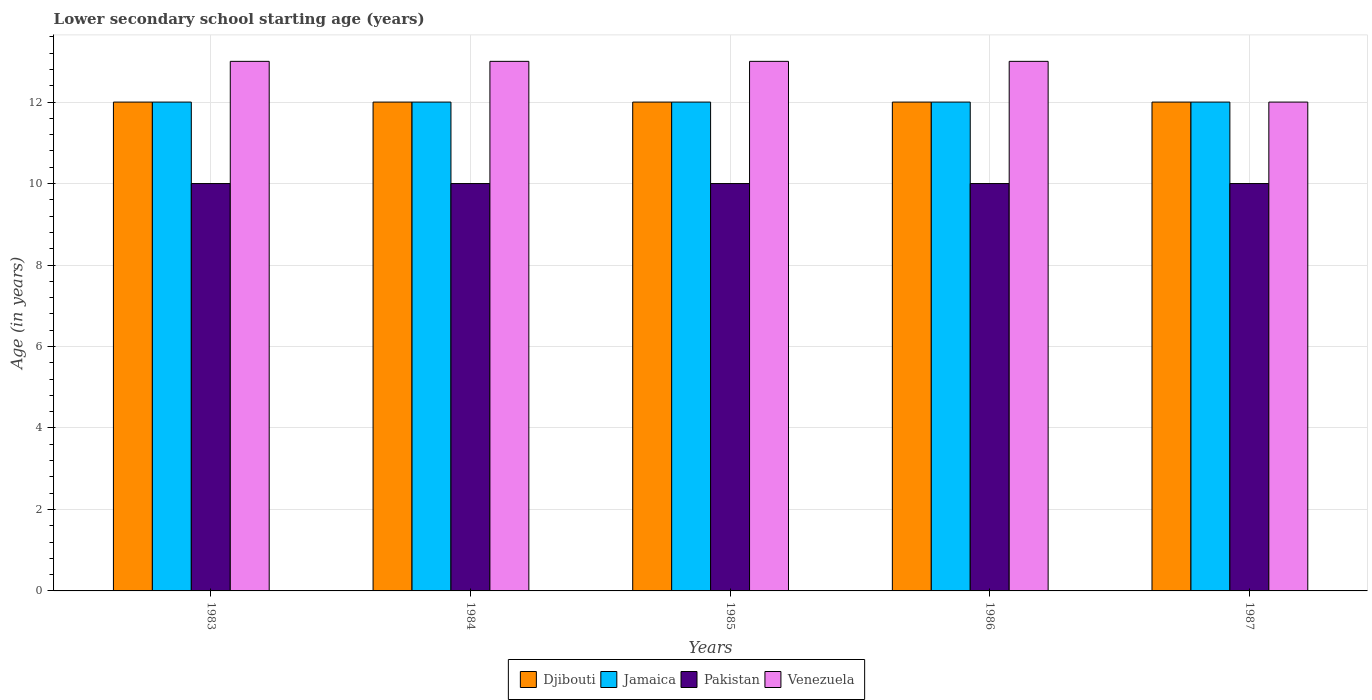Are the number of bars per tick equal to the number of legend labels?
Give a very brief answer. Yes. Are the number of bars on each tick of the X-axis equal?
Your answer should be compact. Yes. How many bars are there on the 2nd tick from the left?
Ensure brevity in your answer.  4. What is the label of the 5th group of bars from the left?
Ensure brevity in your answer.  1987. What is the lower secondary school starting age of children in Jamaica in 1985?
Provide a short and direct response. 12. Across all years, what is the maximum lower secondary school starting age of children in Venezuela?
Provide a succinct answer. 13. Across all years, what is the minimum lower secondary school starting age of children in Pakistan?
Your response must be concise. 10. In which year was the lower secondary school starting age of children in Djibouti minimum?
Your response must be concise. 1983. What is the total lower secondary school starting age of children in Jamaica in the graph?
Offer a very short reply. 60. What is the difference between the lower secondary school starting age of children in Venezuela in 1985 and that in 1987?
Your answer should be compact. 1. What is the difference between the lower secondary school starting age of children in Pakistan in 1983 and the lower secondary school starting age of children in Venezuela in 1985?
Make the answer very short. -3. In the year 1985, what is the difference between the lower secondary school starting age of children in Pakistan and lower secondary school starting age of children in Djibouti?
Make the answer very short. -2. What is the ratio of the lower secondary school starting age of children in Pakistan in 1984 to that in 1985?
Offer a terse response. 1. What is the difference between the highest and the lowest lower secondary school starting age of children in Venezuela?
Provide a short and direct response. 1. Is the sum of the lower secondary school starting age of children in Jamaica in 1983 and 1985 greater than the maximum lower secondary school starting age of children in Venezuela across all years?
Ensure brevity in your answer.  Yes. What does the 2nd bar from the left in 1986 represents?
Offer a terse response. Jamaica. What does the 3rd bar from the right in 1983 represents?
Provide a short and direct response. Jamaica. What is the difference between two consecutive major ticks on the Y-axis?
Give a very brief answer. 2. Are the values on the major ticks of Y-axis written in scientific E-notation?
Your answer should be very brief. No. Does the graph contain grids?
Ensure brevity in your answer.  Yes. How many legend labels are there?
Your answer should be very brief. 4. How are the legend labels stacked?
Offer a very short reply. Horizontal. What is the title of the graph?
Give a very brief answer. Lower secondary school starting age (years). Does "Eritrea" appear as one of the legend labels in the graph?
Your answer should be compact. No. What is the label or title of the Y-axis?
Make the answer very short. Age (in years). What is the Age (in years) in Djibouti in 1983?
Provide a short and direct response. 12. What is the Age (in years) of Jamaica in 1983?
Offer a very short reply. 12. What is the Age (in years) of Pakistan in 1983?
Give a very brief answer. 10. What is the Age (in years) in Djibouti in 1984?
Provide a short and direct response. 12. What is the Age (in years) in Jamaica in 1984?
Ensure brevity in your answer.  12. What is the Age (in years) in Pakistan in 1984?
Make the answer very short. 10. What is the Age (in years) of Venezuela in 1984?
Provide a short and direct response. 13. What is the Age (in years) of Jamaica in 1985?
Your answer should be very brief. 12. What is the Age (in years) in Pakistan in 1985?
Your answer should be very brief. 10. What is the Age (in years) in Venezuela in 1985?
Make the answer very short. 13. What is the Age (in years) in Jamaica in 1986?
Make the answer very short. 12. What is the Age (in years) of Venezuela in 1986?
Make the answer very short. 13. Across all years, what is the maximum Age (in years) in Venezuela?
Give a very brief answer. 13. Across all years, what is the minimum Age (in years) of Djibouti?
Make the answer very short. 12. Across all years, what is the minimum Age (in years) of Jamaica?
Give a very brief answer. 12. Across all years, what is the minimum Age (in years) in Pakistan?
Your answer should be very brief. 10. Across all years, what is the minimum Age (in years) in Venezuela?
Your response must be concise. 12. What is the total Age (in years) in Jamaica in the graph?
Your response must be concise. 60. What is the total Age (in years) of Venezuela in the graph?
Provide a short and direct response. 64. What is the difference between the Age (in years) of Djibouti in 1983 and that in 1984?
Offer a very short reply. 0. What is the difference between the Age (in years) of Pakistan in 1983 and that in 1984?
Your answer should be compact. 0. What is the difference between the Age (in years) in Jamaica in 1983 and that in 1986?
Your answer should be compact. 0. What is the difference between the Age (in years) in Pakistan in 1983 and that in 1986?
Offer a terse response. 0. What is the difference between the Age (in years) in Venezuela in 1983 and that in 1986?
Your answer should be very brief. 0. What is the difference between the Age (in years) in Djibouti in 1983 and that in 1987?
Keep it short and to the point. 0. What is the difference between the Age (in years) in Jamaica in 1983 and that in 1987?
Make the answer very short. 0. What is the difference between the Age (in years) of Venezuela in 1983 and that in 1987?
Offer a very short reply. 1. What is the difference between the Age (in years) of Djibouti in 1984 and that in 1985?
Keep it short and to the point. 0. What is the difference between the Age (in years) of Jamaica in 1984 and that in 1985?
Keep it short and to the point. 0. What is the difference between the Age (in years) in Pakistan in 1984 and that in 1985?
Offer a very short reply. 0. What is the difference between the Age (in years) of Djibouti in 1984 and that in 1986?
Provide a short and direct response. 0. What is the difference between the Age (in years) of Pakistan in 1984 and that in 1986?
Your response must be concise. 0. What is the difference between the Age (in years) of Venezuela in 1984 and that in 1986?
Provide a succinct answer. 0. What is the difference between the Age (in years) in Jamaica in 1984 and that in 1987?
Offer a terse response. 0. What is the difference between the Age (in years) in Venezuela in 1984 and that in 1987?
Provide a succinct answer. 1. What is the difference between the Age (in years) of Djibouti in 1985 and that in 1987?
Give a very brief answer. 0. What is the difference between the Age (in years) of Pakistan in 1985 and that in 1987?
Make the answer very short. 0. What is the difference between the Age (in years) of Venezuela in 1985 and that in 1987?
Ensure brevity in your answer.  1. What is the difference between the Age (in years) in Djibouti in 1986 and that in 1987?
Make the answer very short. 0. What is the difference between the Age (in years) of Pakistan in 1986 and that in 1987?
Ensure brevity in your answer.  0. What is the difference between the Age (in years) of Djibouti in 1983 and the Age (in years) of Jamaica in 1984?
Give a very brief answer. 0. What is the difference between the Age (in years) in Djibouti in 1983 and the Age (in years) in Venezuela in 1984?
Keep it short and to the point. -1. What is the difference between the Age (in years) of Pakistan in 1983 and the Age (in years) of Venezuela in 1984?
Your answer should be very brief. -3. What is the difference between the Age (in years) of Jamaica in 1983 and the Age (in years) of Pakistan in 1985?
Your answer should be compact. 2. What is the difference between the Age (in years) of Jamaica in 1983 and the Age (in years) of Venezuela in 1985?
Ensure brevity in your answer.  -1. What is the difference between the Age (in years) in Pakistan in 1983 and the Age (in years) in Venezuela in 1985?
Provide a succinct answer. -3. What is the difference between the Age (in years) in Djibouti in 1983 and the Age (in years) in Jamaica in 1986?
Your response must be concise. 0. What is the difference between the Age (in years) of Djibouti in 1983 and the Age (in years) of Venezuela in 1986?
Your answer should be compact. -1. What is the difference between the Age (in years) in Jamaica in 1983 and the Age (in years) in Pakistan in 1986?
Ensure brevity in your answer.  2. What is the difference between the Age (in years) of Djibouti in 1983 and the Age (in years) of Pakistan in 1987?
Your answer should be very brief. 2. What is the difference between the Age (in years) of Jamaica in 1983 and the Age (in years) of Pakistan in 1987?
Your answer should be very brief. 2. What is the difference between the Age (in years) of Jamaica in 1983 and the Age (in years) of Venezuela in 1987?
Keep it short and to the point. 0. What is the difference between the Age (in years) in Pakistan in 1983 and the Age (in years) in Venezuela in 1987?
Your response must be concise. -2. What is the difference between the Age (in years) in Djibouti in 1984 and the Age (in years) in Jamaica in 1985?
Your answer should be very brief. 0. What is the difference between the Age (in years) of Djibouti in 1984 and the Age (in years) of Venezuela in 1985?
Offer a very short reply. -1. What is the difference between the Age (in years) in Jamaica in 1984 and the Age (in years) in Pakistan in 1985?
Give a very brief answer. 2. What is the difference between the Age (in years) of Jamaica in 1984 and the Age (in years) of Venezuela in 1985?
Offer a terse response. -1. What is the difference between the Age (in years) in Pakistan in 1984 and the Age (in years) in Venezuela in 1985?
Keep it short and to the point. -3. What is the difference between the Age (in years) in Djibouti in 1984 and the Age (in years) in Pakistan in 1986?
Give a very brief answer. 2. What is the difference between the Age (in years) of Djibouti in 1984 and the Age (in years) of Venezuela in 1986?
Offer a terse response. -1. What is the difference between the Age (in years) of Jamaica in 1984 and the Age (in years) of Pakistan in 1986?
Your answer should be very brief. 2. What is the difference between the Age (in years) in Jamaica in 1984 and the Age (in years) in Venezuela in 1986?
Your answer should be very brief. -1. What is the difference between the Age (in years) in Djibouti in 1984 and the Age (in years) in Jamaica in 1987?
Ensure brevity in your answer.  0. What is the difference between the Age (in years) in Djibouti in 1984 and the Age (in years) in Pakistan in 1987?
Offer a terse response. 2. What is the difference between the Age (in years) of Djibouti in 1984 and the Age (in years) of Venezuela in 1987?
Provide a short and direct response. 0. What is the difference between the Age (in years) in Jamaica in 1984 and the Age (in years) in Pakistan in 1987?
Your response must be concise. 2. What is the difference between the Age (in years) in Pakistan in 1984 and the Age (in years) in Venezuela in 1987?
Make the answer very short. -2. What is the difference between the Age (in years) in Djibouti in 1985 and the Age (in years) in Jamaica in 1986?
Provide a short and direct response. 0. What is the difference between the Age (in years) of Jamaica in 1985 and the Age (in years) of Pakistan in 1986?
Ensure brevity in your answer.  2. What is the difference between the Age (in years) in Jamaica in 1985 and the Age (in years) in Venezuela in 1986?
Ensure brevity in your answer.  -1. What is the difference between the Age (in years) of Jamaica in 1985 and the Age (in years) of Pakistan in 1987?
Give a very brief answer. 2. What is the difference between the Age (in years) in Jamaica in 1985 and the Age (in years) in Venezuela in 1987?
Your answer should be very brief. 0. What is the difference between the Age (in years) in Pakistan in 1985 and the Age (in years) in Venezuela in 1987?
Provide a succinct answer. -2. What is the difference between the Age (in years) in Jamaica in 1986 and the Age (in years) in Pakistan in 1987?
Offer a very short reply. 2. What is the difference between the Age (in years) of Pakistan in 1986 and the Age (in years) of Venezuela in 1987?
Provide a succinct answer. -2. What is the average Age (in years) in Djibouti per year?
Your answer should be very brief. 12. What is the average Age (in years) in Jamaica per year?
Your answer should be compact. 12. What is the average Age (in years) of Venezuela per year?
Keep it short and to the point. 12.8. In the year 1983, what is the difference between the Age (in years) in Djibouti and Age (in years) in Pakistan?
Offer a terse response. 2. In the year 1983, what is the difference between the Age (in years) of Djibouti and Age (in years) of Venezuela?
Make the answer very short. -1. In the year 1983, what is the difference between the Age (in years) of Jamaica and Age (in years) of Venezuela?
Provide a short and direct response. -1. In the year 1984, what is the difference between the Age (in years) in Djibouti and Age (in years) in Jamaica?
Make the answer very short. 0. In the year 1984, what is the difference between the Age (in years) in Jamaica and Age (in years) in Pakistan?
Your answer should be compact. 2. In the year 1984, what is the difference between the Age (in years) in Jamaica and Age (in years) in Venezuela?
Ensure brevity in your answer.  -1. In the year 1985, what is the difference between the Age (in years) in Djibouti and Age (in years) in Jamaica?
Your answer should be compact. 0. In the year 1985, what is the difference between the Age (in years) of Djibouti and Age (in years) of Venezuela?
Keep it short and to the point. -1. In the year 1985, what is the difference between the Age (in years) in Jamaica and Age (in years) in Venezuela?
Provide a succinct answer. -1. In the year 1985, what is the difference between the Age (in years) of Pakistan and Age (in years) of Venezuela?
Keep it short and to the point. -3. In the year 1986, what is the difference between the Age (in years) in Djibouti and Age (in years) in Venezuela?
Your answer should be compact. -1. In the year 1986, what is the difference between the Age (in years) of Jamaica and Age (in years) of Venezuela?
Give a very brief answer. -1. In the year 1987, what is the difference between the Age (in years) of Djibouti and Age (in years) of Jamaica?
Give a very brief answer. 0. In the year 1987, what is the difference between the Age (in years) of Djibouti and Age (in years) of Pakistan?
Provide a short and direct response. 2. In the year 1987, what is the difference between the Age (in years) of Djibouti and Age (in years) of Venezuela?
Keep it short and to the point. 0. In the year 1987, what is the difference between the Age (in years) in Jamaica and Age (in years) in Pakistan?
Make the answer very short. 2. In the year 1987, what is the difference between the Age (in years) of Jamaica and Age (in years) of Venezuela?
Make the answer very short. 0. What is the ratio of the Age (in years) of Djibouti in 1983 to that in 1984?
Your answer should be compact. 1. What is the ratio of the Age (in years) in Venezuela in 1983 to that in 1984?
Ensure brevity in your answer.  1. What is the ratio of the Age (in years) of Djibouti in 1983 to that in 1985?
Keep it short and to the point. 1. What is the ratio of the Age (in years) in Jamaica in 1983 to that in 1985?
Make the answer very short. 1. What is the ratio of the Age (in years) in Pakistan in 1983 to that in 1985?
Keep it short and to the point. 1. What is the ratio of the Age (in years) of Jamaica in 1983 to that in 1986?
Offer a very short reply. 1. What is the ratio of the Age (in years) in Venezuela in 1983 to that in 1987?
Give a very brief answer. 1.08. What is the ratio of the Age (in years) of Djibouti in 1984 to that in 1985?
Keep it short and to the point. 1. What is the ratio of the Age (in years) of Jamaica in 1984 to that in 1985?
Keep it short and to the point. 1. What is the ratio of the Age (in years) of Pakistan in 1984 to that in 1985?
Offer a very short reply. 1. What is the ratio of the Age (in years) of Venezuela in 1984 to that in 1985?
Your answer should be compact. 1. What is the ratio of the Age (in years) in Djibouti in 1984 to that in 1986?
Provide a succinct answer. 1. What is the ratio of the Age (in years) of Jamaica in 1984 to that in 1986?
Give a very brief answer. 1. What is the ratio of the Age (in years) of Pakistan in 1984 to that in 1986?
Offer a terse response. 1. What is the ratio of the Age (in years) of Venezuela in 1984 to that in 1987?
Your answer should be compact. 1.08. What is the ratio of the Age (in years) of Jamaica in 1985 to that in 1986?
Your answer should be compact. 1. What is the ratio of the Age (in years) in Djibouti in 1985 to that in 1987?
Your response must be concise. 1. What is the ratio of the Age (in years) in Jamaica in 1985 to that in 1987?
Provide a short and direct response. 1. What is the ratio of the Age (in years) in Pakistan in 1985 to that in 1987?
Make the answer very short. 1. What is the ratio of the Age (in years) in Venezuela in 1985 to that in 1987?
Make the answer very short. 1.08. What is the ratio of the Age (in years) of Djibouti in 1986 to that in 1987?
Your answer should be compact. 1. What is the ratio of the Age (in years) in Jamaica in 1986 to that in 1987?
Offer a very short reply. 1. What is the ratio of the Age (in years) in Pakistan in 1986 to that in 1987?
Your answer should be compact. 1. What is the difference between the highest and the lowest Age (in years) in Jamaica?
Offer a very short reply. 0. What is the difference between the highest and the lowest Age (in years) in Pakistan?
Ensure brevity in your answer.  0. What is the difference between the highest and the lowest Age (in years) in Venezuela?
Keep it short and to the point. 1. 